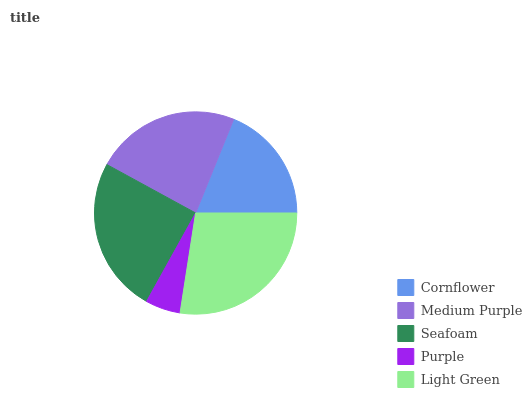Is Purple the minimum?
Answer yes or no. Yes. Is Light Green the maximum?
Answer yes or no. Yes. Is Medium Purple the minimum?
Answer yes or no. No. Is Medium Purple the maximum?
Answer yes or no. No. Is Medium Purple greater than Cornflower?
Answer yes or no. Yes. Is Cornflower less than Medium Purple?
Answer yes or no. Yes. Is Cornflower greater than Medium Purple?
Answer yes or no. No. Is Medium Purple less than Cornflower?
Answer yes or no. No. Is Medium Purple the high median?
Answer yes or no. Yes. Is Medium Purple the low median?
Answer yes or no. Yes. Is Cornflower the high median?
Answer yes or no. No. Is Light Green the low median?
Answer yes or no. No. 